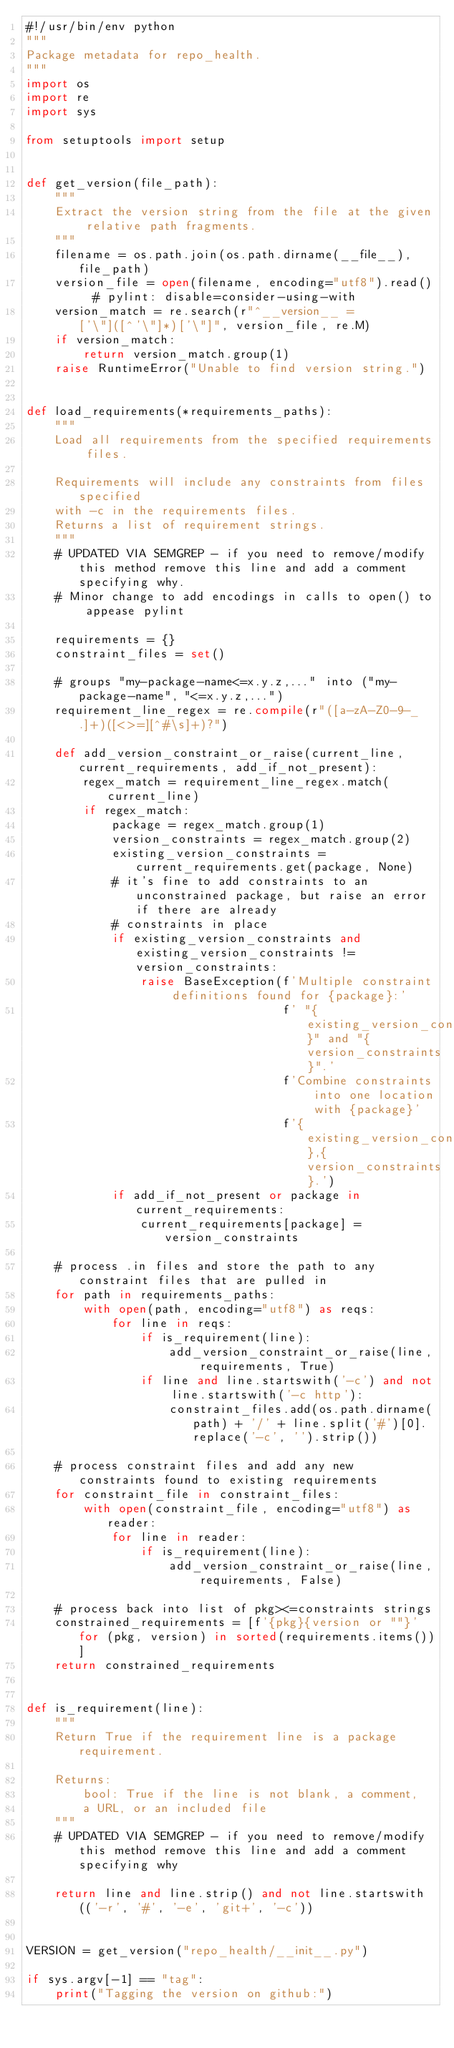Convert code to text. <code><loc_0><loc_0><loc_500><loc_500><_Python_>#!/usr/bin/env python
"""
Package metadata for repo_health.
"""
import os
import re
import sys

from setuptools import setup


def get_version(file_path):
    """
    Extract the version string from the file at the given relative path fragments.
    """
    filename = os.path.join(os.path.dirname(__file__), file_path)
    version_file = open(filename, encoding="utf8").read()  # pylint: disable=consider-using-with
    version_match = re.search(r"^__version__ = ['\"]([^'\"]*)['\"]", version_file, re.M)
    if version_match:
        return version_match.group(1)
    raise RuntimeError("Unable to find version string.")


def load_requirements(*requirements_paths):
    """
    Load all requirements from the specified requirements files.

    Requirements will include any constraints from files specified
    with -c in the requirements files.
    Returns a list of requirement strings.
    """
    # UPDATED VIA SEMGREP - if you need to remove/modify this method remove this line and add a comment specifying why.
    # Minor change to add encodings in calls to open() to appease pylint

    requirements = {}
    constraint_files = set()

    # groups "my-package-name<=x.y.z,..." into ("my-package-name", "<=x.y.z,...")
    requirement_line_regex = re.compile(r"([a-zA-Z0-9-_.]+)([<>=][^#\s]+)?")

    def add_version_constraint_or_raise(current_line, current_requirements, add_if_not_present):
        regex_match = requirement_line_regex.match(current_line)
        if regex_match:
            package = regex_match.group(1)
            version_constraints = regex_match.group(2)
            existing_version_constraints = current_requirements.get(package, None)
            # it's fine to add constraints to an unconstrained package, but raise an error if there are already
            # constraints in place
            if existing_version_constraints and existing_version_constraints != version_constraints:
                raise BaseException(f'Multiple constraint definitions found for {package}:'
                                    f' "{existing_version_constraints}" and "{version_constraints}".'
                                    f'Combine constraints into one location with {package}'
                                    f'{existing_version_constraints},{version_constraints}.')
            if add_if_not_present or package in current_requirements:
                current_requirements[package] = version_constraints

    # process .in files and store the path to any constraint files that are pulled in
    for path in requirements_paths:
        with open(path, encoding="utf8") as reqs:
            for line in reqs:
                if is_requirement(line):
                    add_version_constraint_or_raise(line, requirements, True)
                if line and line.startswith('-c') and not line.startswith('-c http'):
                    constraint_files.add(os.path.dirname(path) + '/' + line.split('#')[0].replace('-c', '').strip())

    # process constraint files and add any new constraints found to existing requirements
    for constraint_file in constraint_files:
        with open(constraint_file, encoding="utf8") as reader:
            for line in reader:
                if is_requirement(line):
                    add_version_constraint_or_raise(line, requirements, False)

    # process back into list of pkg><=constraints strings
    constrained_requirements = [f'{pkg}{version or ""}' for (pkg, version) in sorted(requirements.items())]
    return constrained_requirements


def is_requirement(line):
    """
    Return True if the requirement line is a package requirement.

    Returns:
        bool: True if the line is not blank, a comment,
        a URL, or an included file
    """
    # UPDATED VIA SEMGREP - if you need to remove/modify this method remove this line and add a comment specifying why

    return line and line.strip() and not line.startswith(('-r', '#', '-e', 'git+', '-c'))


VERSION = get_version("repo_health/__init__.py")

if sys.argv[-1] == "tag":
    print("Tagging the version on github:")</code> 